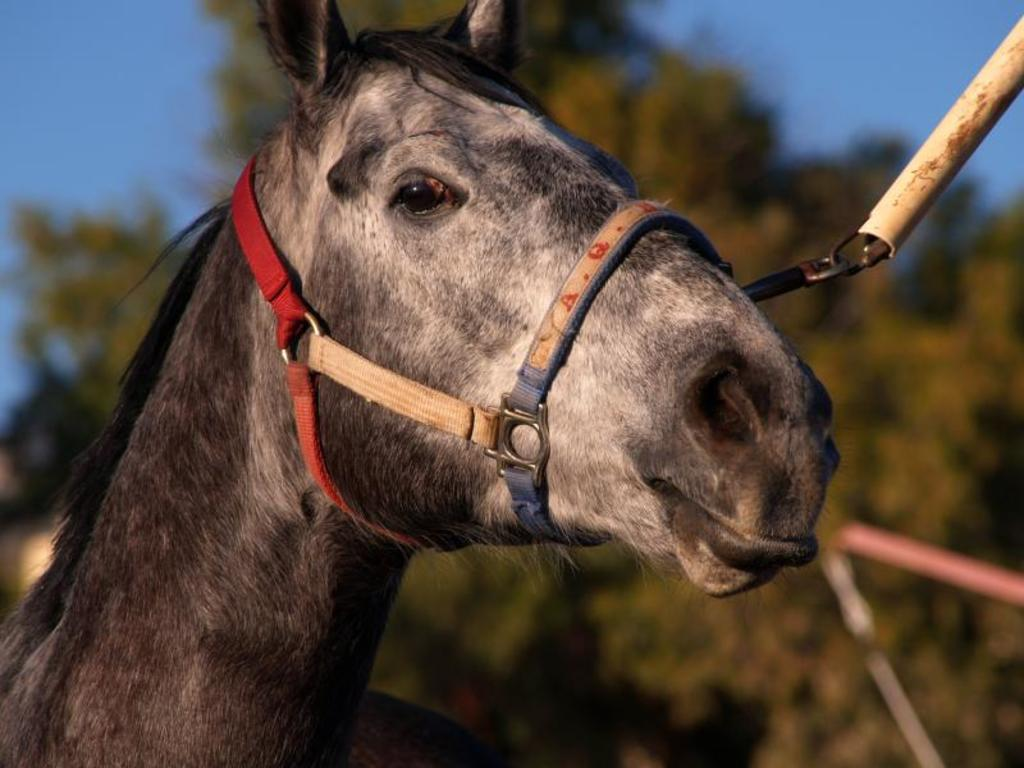What type of animal is in the image? The type of animal cannot be determined from the provided facts. In which direction is the animal facing? The animal is facing towards the right side. What can be seen in the background of the image? There are trees in the background of the image. What is visible at the top of the image? The sky is visible at the top of the image. What color is the grape that the animal is holding in the image? There is no grape present in the image, and the animal is not holding anything. Where is the office located in the image? There is no office present in the image. 